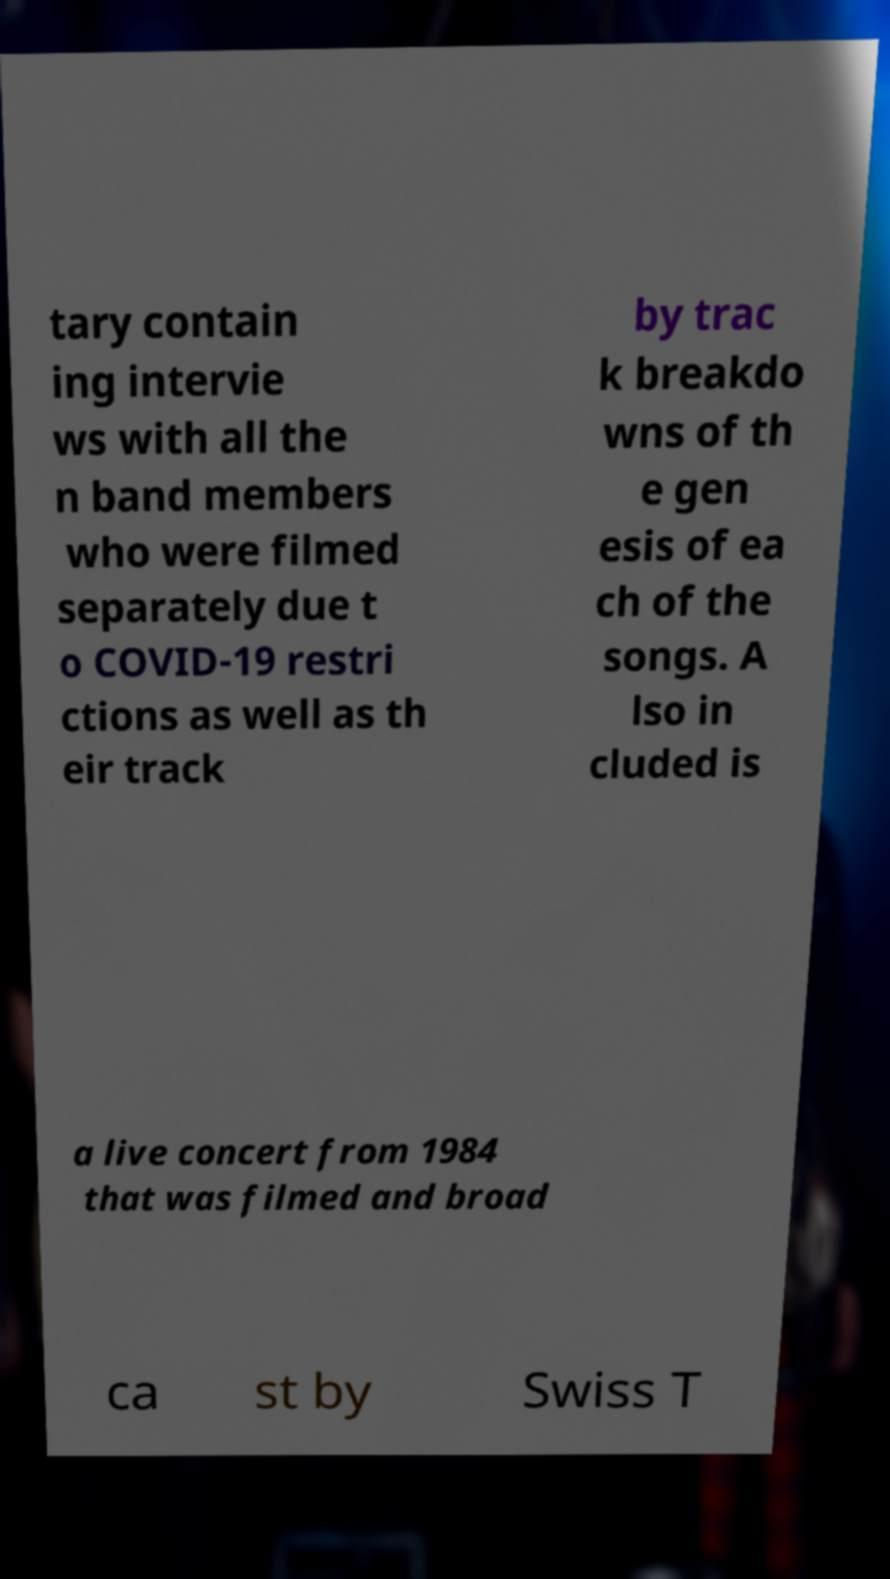I need the written content from this picture converted into text. Can you do that? tary contain ing intervie ws with all the n band members who were filmed separately due t o COVID-19 restri ctions as well as th eir track by trac k breakdo wns of th e gen esis of ea ch of the songs. A lso in cluded is a live concert from 1984 that was filmed and broad ca st by Swiss T 